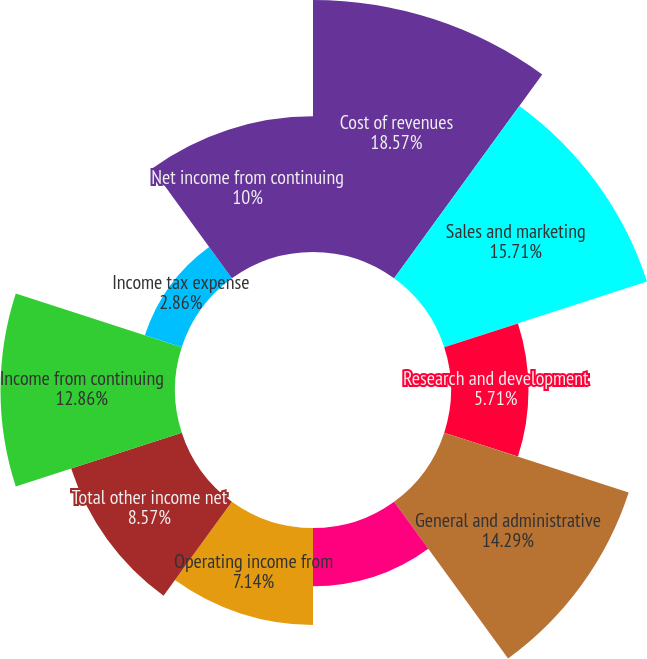Convert chart to OTSL. <chart><loc_0><loc_0><loc_500><loc_500><pie_chart><fcel>Cost of revenues<fcel>Sales and marketing<fcel>Research and development<fcel>General and administrative<fcel>Restructuring impairment and<fcel>Operating income from<fcel>Total other income net<fcel>Income from continuing<fcel>Income tax expense<fcel>Net income from continuing<nl><fcel>18.57%<fcel>15.71%<fcel>5.71%<fcel>14.29%<fcel>4.29%<fcel>7.14%<fcel>8.57%<fcel>12.86%<fcel>2.86%<fcel>10.0%<nl></chart> 